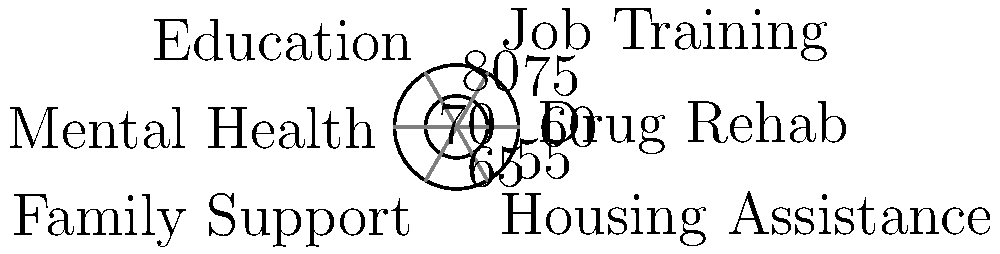The polar coordinate plot shows the success rates of various rehabilitation programs for individuals transitioning out of prison. Which program has the highest success rate, and what is the difference between the highest and lowest success rates? To answer this question, we need to follow these steps:

1. Identify the success rates for each program:
   - Drug Rehab: 60%
   - Job Training: 75%
   - Education: 80%
   - Mental Health: 70%
   - Family Support: 65%
   - Housing Assistance: 55%

2. Find the program with the highest success rate:
   The highest success rate is 80%, which corresponds to the Education program.

3. Find the program with the lowest success rate:
   The lowest success rate is 55%, which corresponds to the Housing Assistance program.

4. Calculate the difference between the highest and lowest success rates:
   $80\% - 55\% = 25\%$

Therefore, the Education program has the highest success rate, and the difference between the highest (Education) and lowest (Housing Assistance) success rates is 25%.
Answer: Education; 25% 